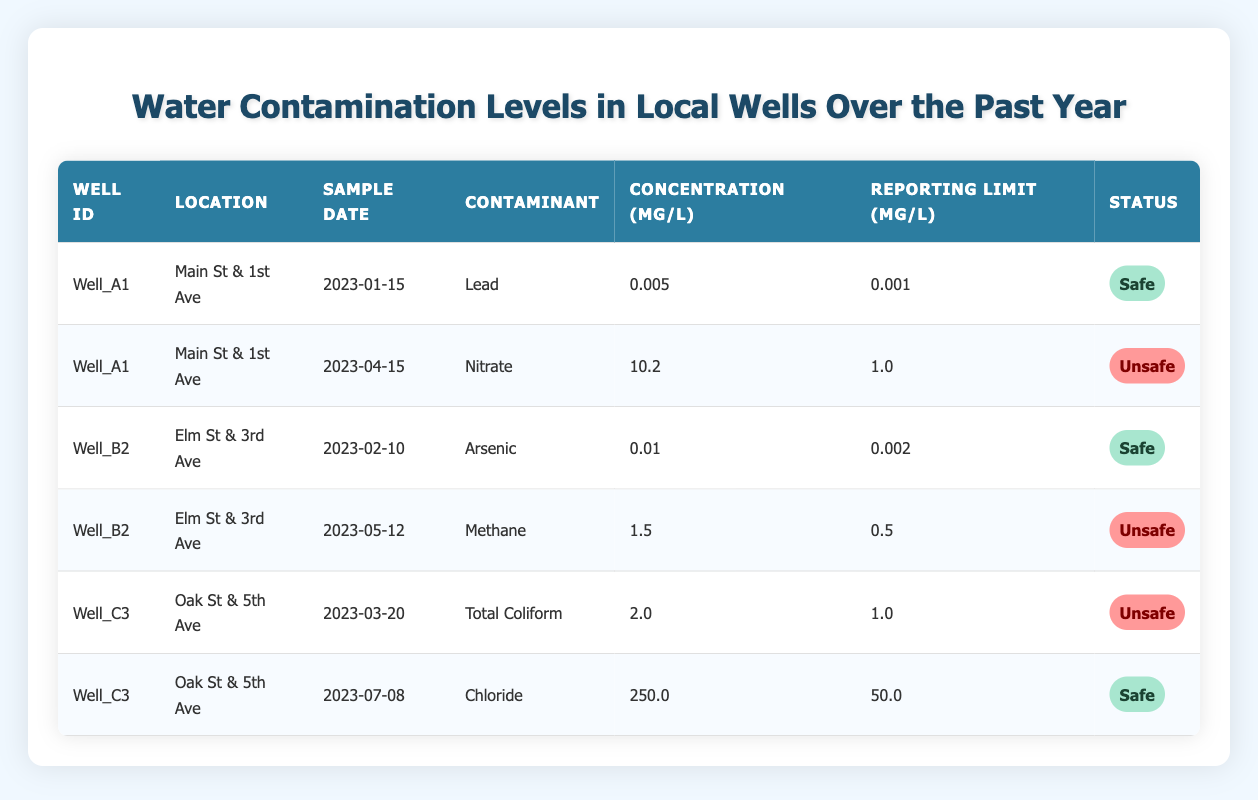What was the highest contaminant concentration recorded among the wells? The data shows different contaminants and their concentrations. The maximum concentration can be identified by comparing each concentration value: Lead (0.005), Nitrate (10.2), Arsenic (0.01), Methane (1.5), Total Coliform (2.0), and Chloride (250.0). The highest value is Chloride at 250.0 mg/L.
Answer: 250.0 mg/L How many wells had unsafe levels of contaminants? By inspecting the status of each entry, we find that "Well_A1" had one unsafe level for Nitrate, "Well_B2" had one unsafe level for Methane, and "Well_C3" had one unsafe level for Total Coliform, making a total of three wells with unsafe levels.
Answer: 3 What is the concentration difference between the highest and lowest concentrations of contaminants? The highest concentration is Chloride (250.0 mg/L) and the lowest is Lead (0.005 mg/L). The difference is calculated by subtracting the lowest from the highest: 250.0 - 0.005 = 249.995 mg/L.
Answer: 249.995 mg/L Is there any well where all contaminant levels are safe? Reviewing the table, "Well_A1" had one safe level and one unsafe level, "Well_B2" had one safe level and one unsafe level, and "Well_C3" had one safe level and one unsafe level. Thus, there is no well that had all safe levels of contaminants.
Answer: No Which contaminant was detected at the location of Main St & 1st Ave, and what was its status? "Well_A1" at Main St & 1st Ave had two samples: one for Lead (safe) and one for Nitrate (unsafe). Therefore, the contaminant detected was Nitrate, and its status was unsafe.
Answer: Nitrate, unsafe What is the average concentration of contaminants for each well? For "Well_A1," the average is (0.005 + 10.2) / 2 = 5.1025 mg/L. For "Well_B2," the average is (0.01 + 1.5) / 2 = 0.755 mg/L. For "Well_C3," the average is (2.0 + 250.0) / 2 = 126.0 mg/L. So the averages are Well_A1: 5.1025 mg/L, Well_B2: 0.755 mg/L, Well_C3: 126.0 mg/L.
Answer: Well_A1: 5.1025 mg/L, Well_B2: 0.755 mg/L, Well_C3: 126.0 mg/L Which well had the most recent sample date, and what was the contaminant found? The data shows entries from different sample dates. The most recent sample was from "Well_C3" on 2023-07-08 with Chloride as the contaminant.
Answer: Well_C3, Chloride What contaminants are found at "Elm St & 3rd Ave"? Checking the data for "Well_B2" at Elm St & 3rd Ave, we see that it had two contaminants: Arsenic (safe) and Methane (unsafe).
Answer: Arsenic, Methane 